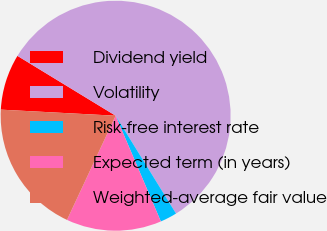Convert chart to OTSL. <chart><loc_0><loc_0><loc_500><loc_500><pie_chart><fcel>Dividend yield<fcel>Volatility<fcel>Risk-free interest rate<fcel>Expected term (in years)<fcel>Weighted-average fair value<nl><fcel>7.87%<fcel>57.49%<fcel>2.37%<fcel>13.38%<fcel>18.89%<nl></chart> 